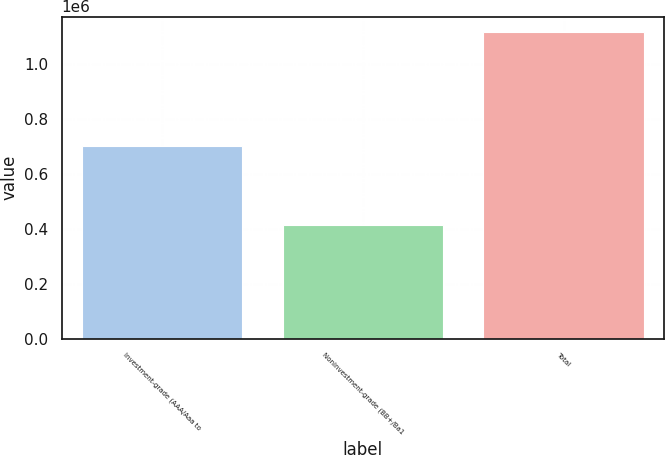<chart> <loc_0><loc_0><loc_500><loc_500><bar_chart><fcel>Investment-grade (AAA/Aaa to<fcel>Noninvestment-grade (BB+/Ba1<fcel>Total<nl><fcel>701775<fcel>413457<fcel>1.11523e+06<nl></chart> 